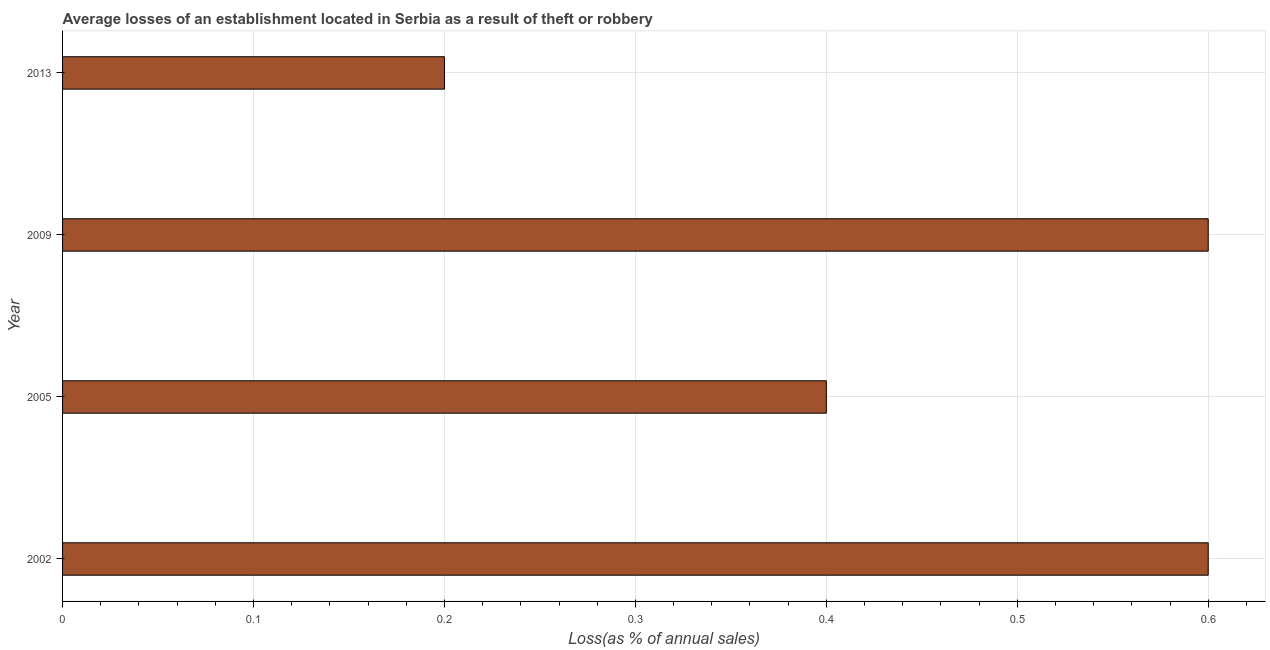What is the title of the graph?
Give a very brief answer. Average losses of an establishment located in Serbia as a result of theft or robbery. What is the label or title of the X-axis?
Provide a succinct answer. Loss(as % of annual sales). What is the label or title of the Y-axis?
Your answer should be very brief. Year. Across all years, what is the maximum losses due to theft?
Provide a short and direct response. 0.6. In which year was the losses due to theft minimum?
Make the answer very short. 2013. What is the sum of the losses due to theft?
Your answer should be compact. 1.8. What is the difference between the losses due to theft in 2002 and 2009?
Give a very brief answer. 0. What is the average losses due to theft per year?
Provide a short and direct response. 0.45. In how many years, is the losses due to theft greater than 0.42 %?
Your response must be concise. 2. Do a majority of the years between 2002 and 2009 (inclusive) have losses due to theft greater than 0.34 %?
Ensure brevity in your answer.  Yes. What is the ratio of the losses due to theft in 2005 to that in 2009?
Offer a terse response. 0.67. Is the losses due to theft in 2002 less than that in 2013?
Give a very brief answer. No. What is the difference between the highest and the second highest losses due to theft?
Offer a very short reply. 0. Is the sum of the losses due to theft in 2002 and 2005 greater than the maximum losses due to theft across all years?
Make the answer very short. Yes. In how many years, is the losses due to theft greater than the average losses due to theft taken over all years?
Keep it short and to the point. 2. How many bars are there?
Provide a short and direct response. 4. How many years are there in the graph?
Make the answer very short. 4. What is the Loss(as % of annual sales) in 2005?
Give a very brief answer. 0.4. What is the Loss(as % of annual sales) of 2009?
Provide a short and direct response. 0.6. What is the difference between the Loss(as % of annual sales) in 2002 and 2013?
Make the answer very short. 0.4. What is the difference between the Loss(as % of annual sales) in 2005 and 2009?
Offer a terse response. -0.2. What is the difference between the Loss(as % of annual sales) in 2009 and 2013?
Your answer should be very brief. 0.4. What is the ratio of the Loss(as % of annual sales) in 2005 to that in 2009?
Your answer should be compact. 0.67. What is the ratio of the Loss(as % of annual sales) in 2005 to that in 2013?
Your response must be concise. 2. 